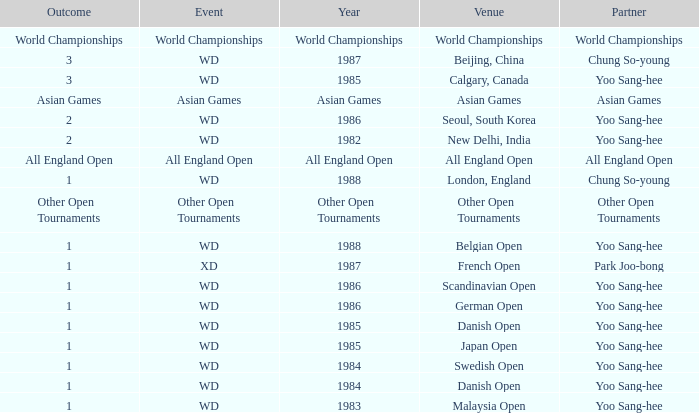Could you parse the entire table? {'header': ['Outcome', 'Event', 'Year', 'Venue', 'Partner'], 'rows': [['World Championships', 'World Championships', 'World Championships', 'World Championships', 'World Championships'], ['3', 'WD', '1987', 'Beijing, China', 'Chung So-young'], ['3', 'WD', '1985', 'Calgary, Canada', 'Yoo Sang-hee'], ['Asian Games', 'Asian Games', 'Asian Games', 'Asian Games', 'Asian Games'], ['2', 'WD', '1986', 'Seoul, South Korea', 'Yoo Sang-hee'], ['2', 'WD', '1982', 'New Delhi, India', 'Yoo Sang-hee'], ['All England Open', 'All England Open', 'All England Open', 'All England Open', 'All England Open'], ['1', 'WD', '1988', 'London, England', 'Chung So-young'], ['Other Open Tournaments', 'Other Open Tournaments', 'Other Open Tournaments', 'Other Open Tournaments', 'Other Open Tournaments'], ['1', 'WD', '1988', 'Belgian Open', 'Yoo Sang-hee'], ['1', 'XD', '1987', 'French Open', 'Park Joo-bong'], ['1', 'WD', '1986', 'Scandinavian Open', 'Yoo Sang-hee'], ['1', 'WD', '1986', 'German Open', 'Yoo Sang-hee'], ['1', 'WD', '1985', 'Danish Open', 'Yoo Sang-hee'], ['1', 'WD', '1985', 'Japan Open', 'Yoo Sang-hee'], ['1', 'WD', '1984', 'Swedish Open', 'Yoo Sang-hee'], ['1', 'WD', '1984', 'Danish Open', 'Yoo Sang-hee'], ['1', 'WD', '1983', 'Malaysia Open', 'Yoo Sang-hee']]} What was the Outcome in 1983 of the WD Event? 1.0. 